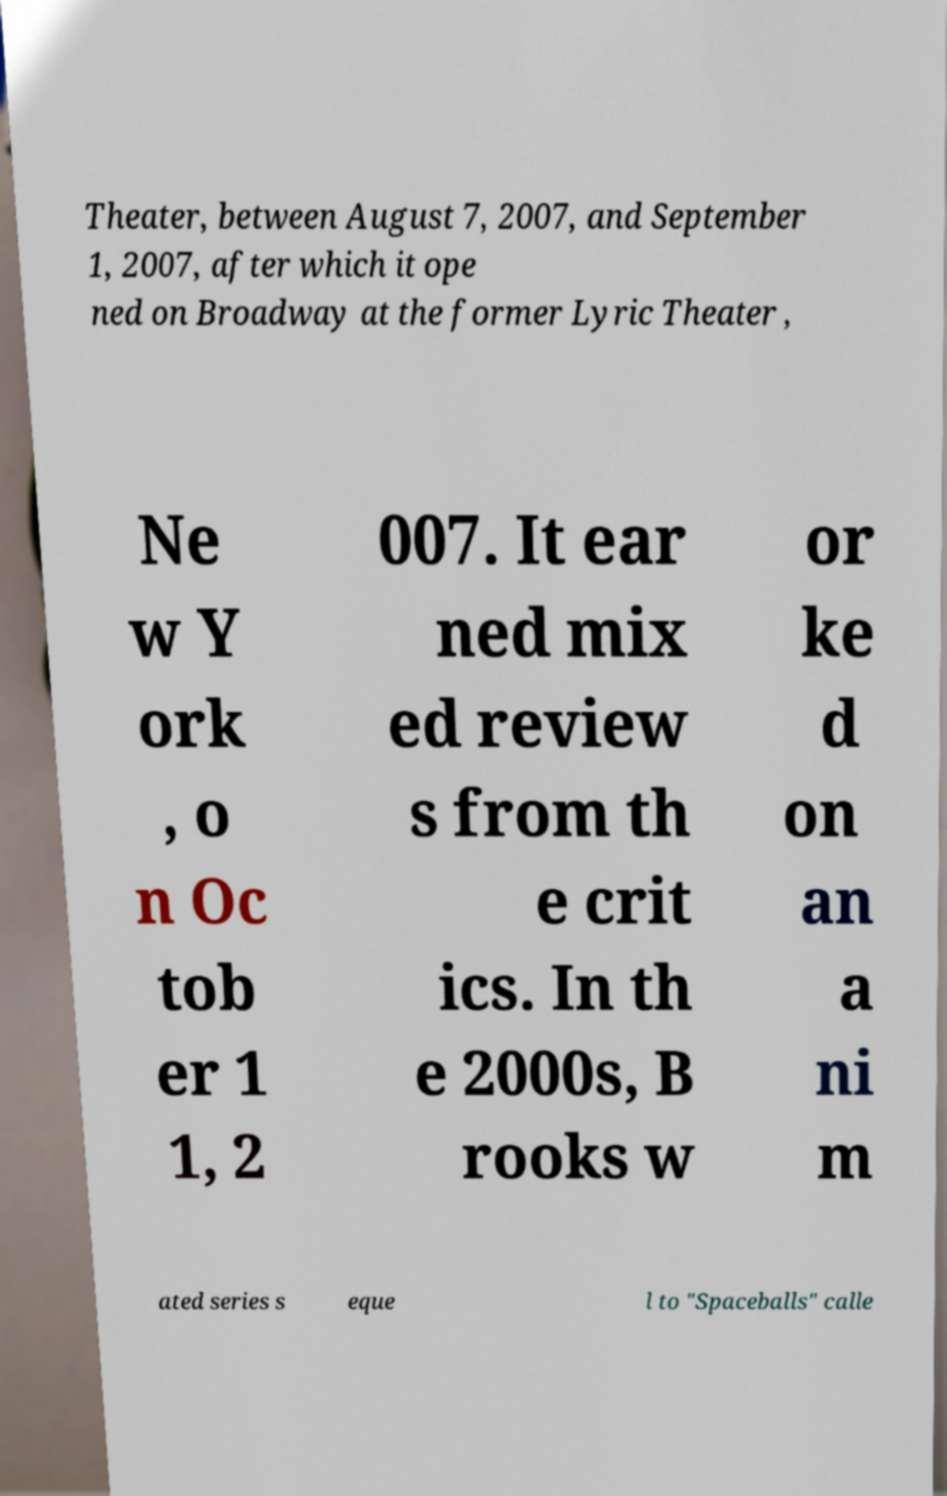I need the written content from this picture converted into text. Can you do that? Theater, between August 7, 2007, and September 1, 2007, after which it ope ned on Broadway at the former Lyric Theater , Ne w Y ork , o n Oc tob er 1 1, 2 007. It ear ned mix ed review s from th e crit ics. In th e 2000s, B rooks w or ke d on an a ni m ated series s eque l to "Spaceballs" calle 